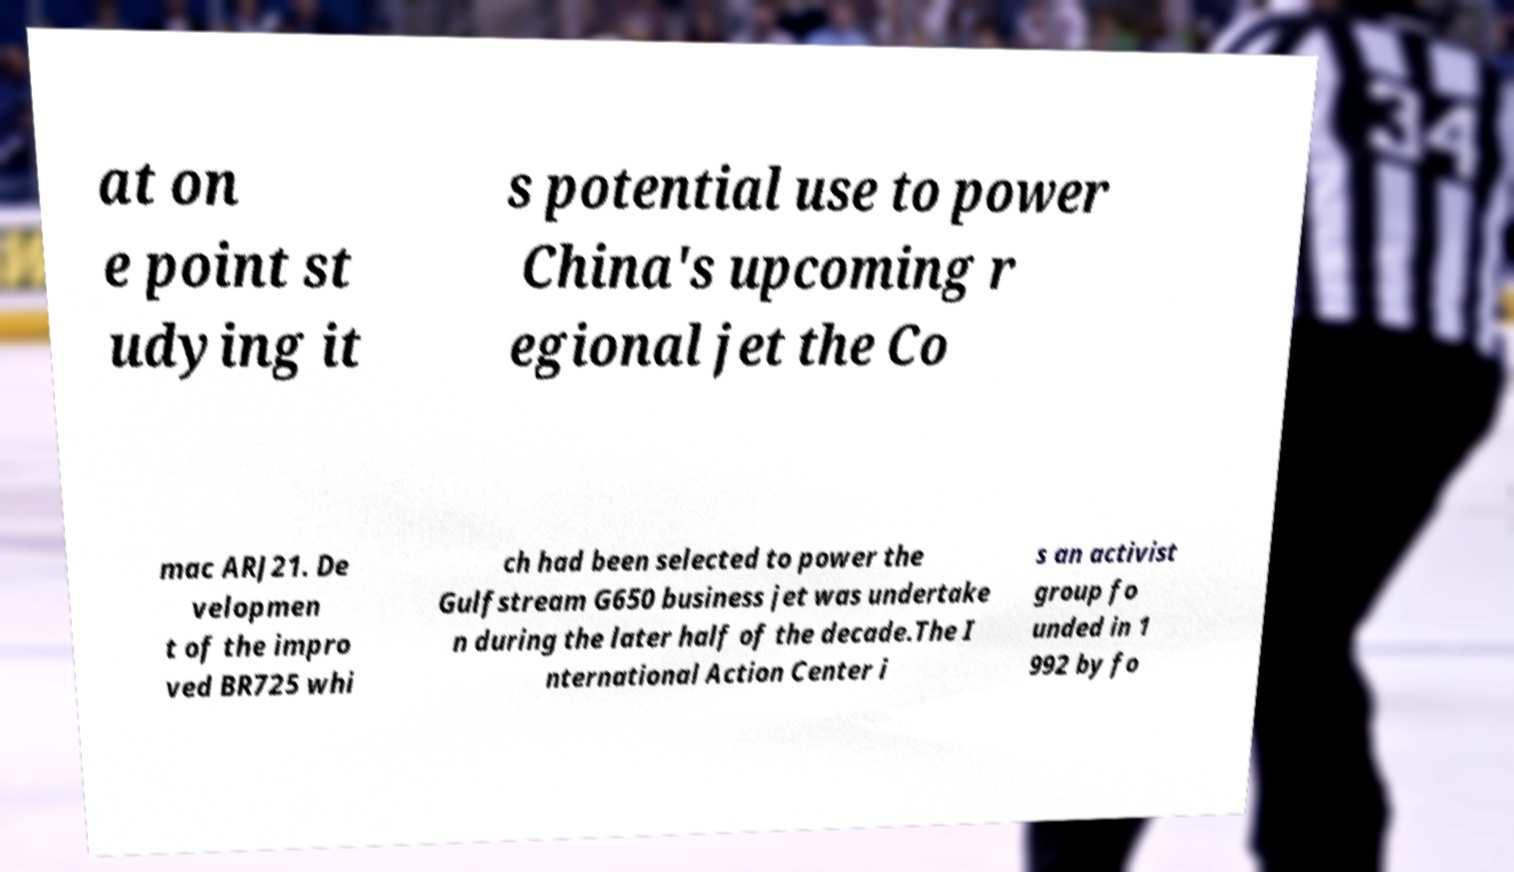What messages or text are displayed in this image? I need them in a readable, typed format. at on e point st udying it s potential use to power China's upcoming r egional jet the Co mac ARJ21. De velopmen t of the impro ved BR725 whi ch had been selected to power the Gulfstream G650 business jet was undertake n during the later half of the decade.The I nternational Action Center i s an activist group fo unded in 1 992 by fo 